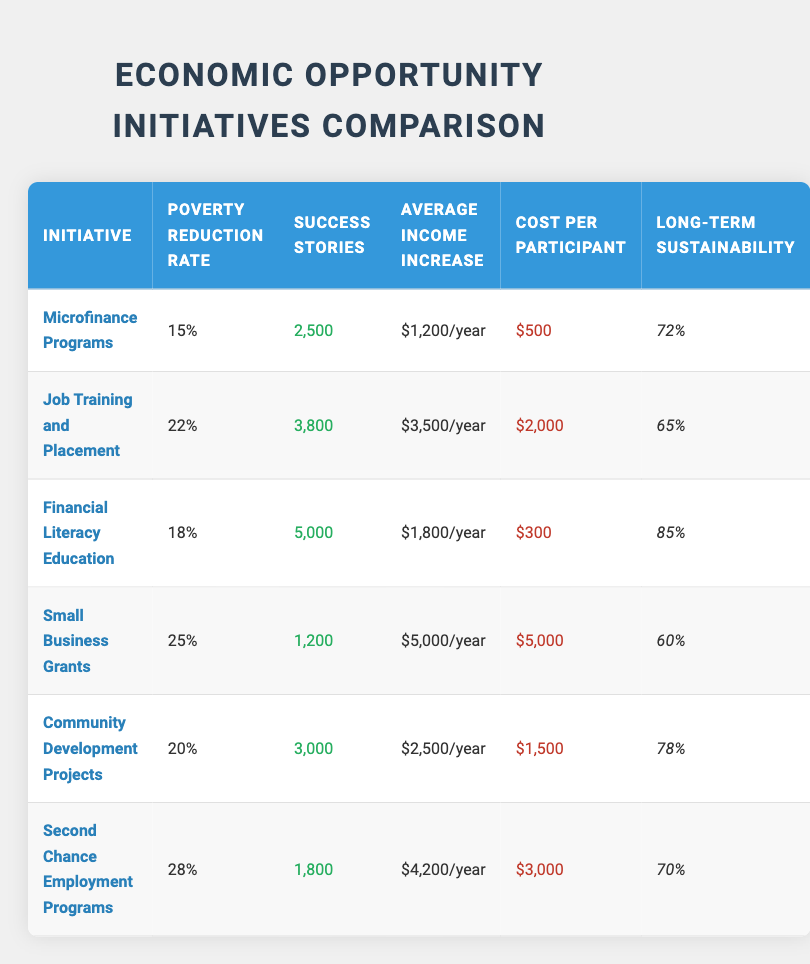What is the average poverty reduction rate of all initiatives? To find the average poverty reduction rate, we first convert the percentage values from the table: 15%, 22%, 18%, 25%, 20%, and 28%. We sum these values: 15 + 22 + 18 + 25 + 20 + 28 = 128. There are a total of 6 initiatives, so the average is 128/6 = 21.33%.
Answer: 21.33% Which initiative has the highest average income increase? By reviewing the average income increase for each initiative: Microfinance Programs ($1,200/year), Job Training and Placement ($3,500/year), Financial Literacy Education ($1,800/year), Small Business Grants ($5,000/year), Community Development Projects ($2,500/year), and Second Chance Employment Programs ($4,200/year). The highest value among these is $5,000/year from Small Business Grants.
Answer: Small Business Grants Did Financial Literacy Education have more success stories than Job Training and Placement? Looking at the success stories, Financial Literacy Education had 5,000 success stories, while Job Training and Placement had 3,800 success stories. Since 5,000 is greater than 3,800, the answer is yes.
Answer: Yes What is the cost per participant of the initiative with the lowest poverty reduction rate? The initiative with the lowest poverty reduction rate is Microfinance Programs at 15%. Its cost per participant is $500, as noted in the table.
Answer: $500 Which two initiatives together have a combined long-term sustainability percentage greater than 150%? First, we take the long-term sustainability percentages for each initiative: Microfinance Programs (72%), Job Training and Placement (65%), Financial Literacy Education (85%), Small Business Grants (60%), Community Development Projects (78%), and Second Chance Employment Programs (70%). The pairs to evaluate are: Microfinance and Job Training (137%), Microfinance and Financial Literacy (157%), Job Training and Financial Literacy (153%), and so forth. The combination of Microfinance and Financial Literacy gives us a total of 157%, which is greater than 150%.
Answer: Microfinance Programs and Financial Literacy Education Does the Second Chance Employment Programs have a higher success story count than the Small Business Grants? Second Chance Employment Programs has 1,800 success stories while Small Business Grants has 1,200. Comparing these values, since 1,800 is greater than 1,200, the answer is yes.
Answer: Yes 